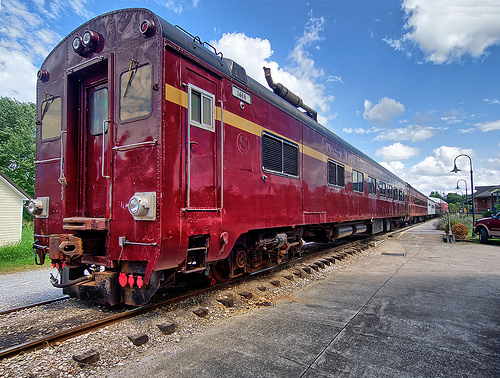<image>
Can you confirm if the train is behind the road? Yes. From this viewpoint, the train is positioned behind the road, with the road partially or fully occluding the train. 